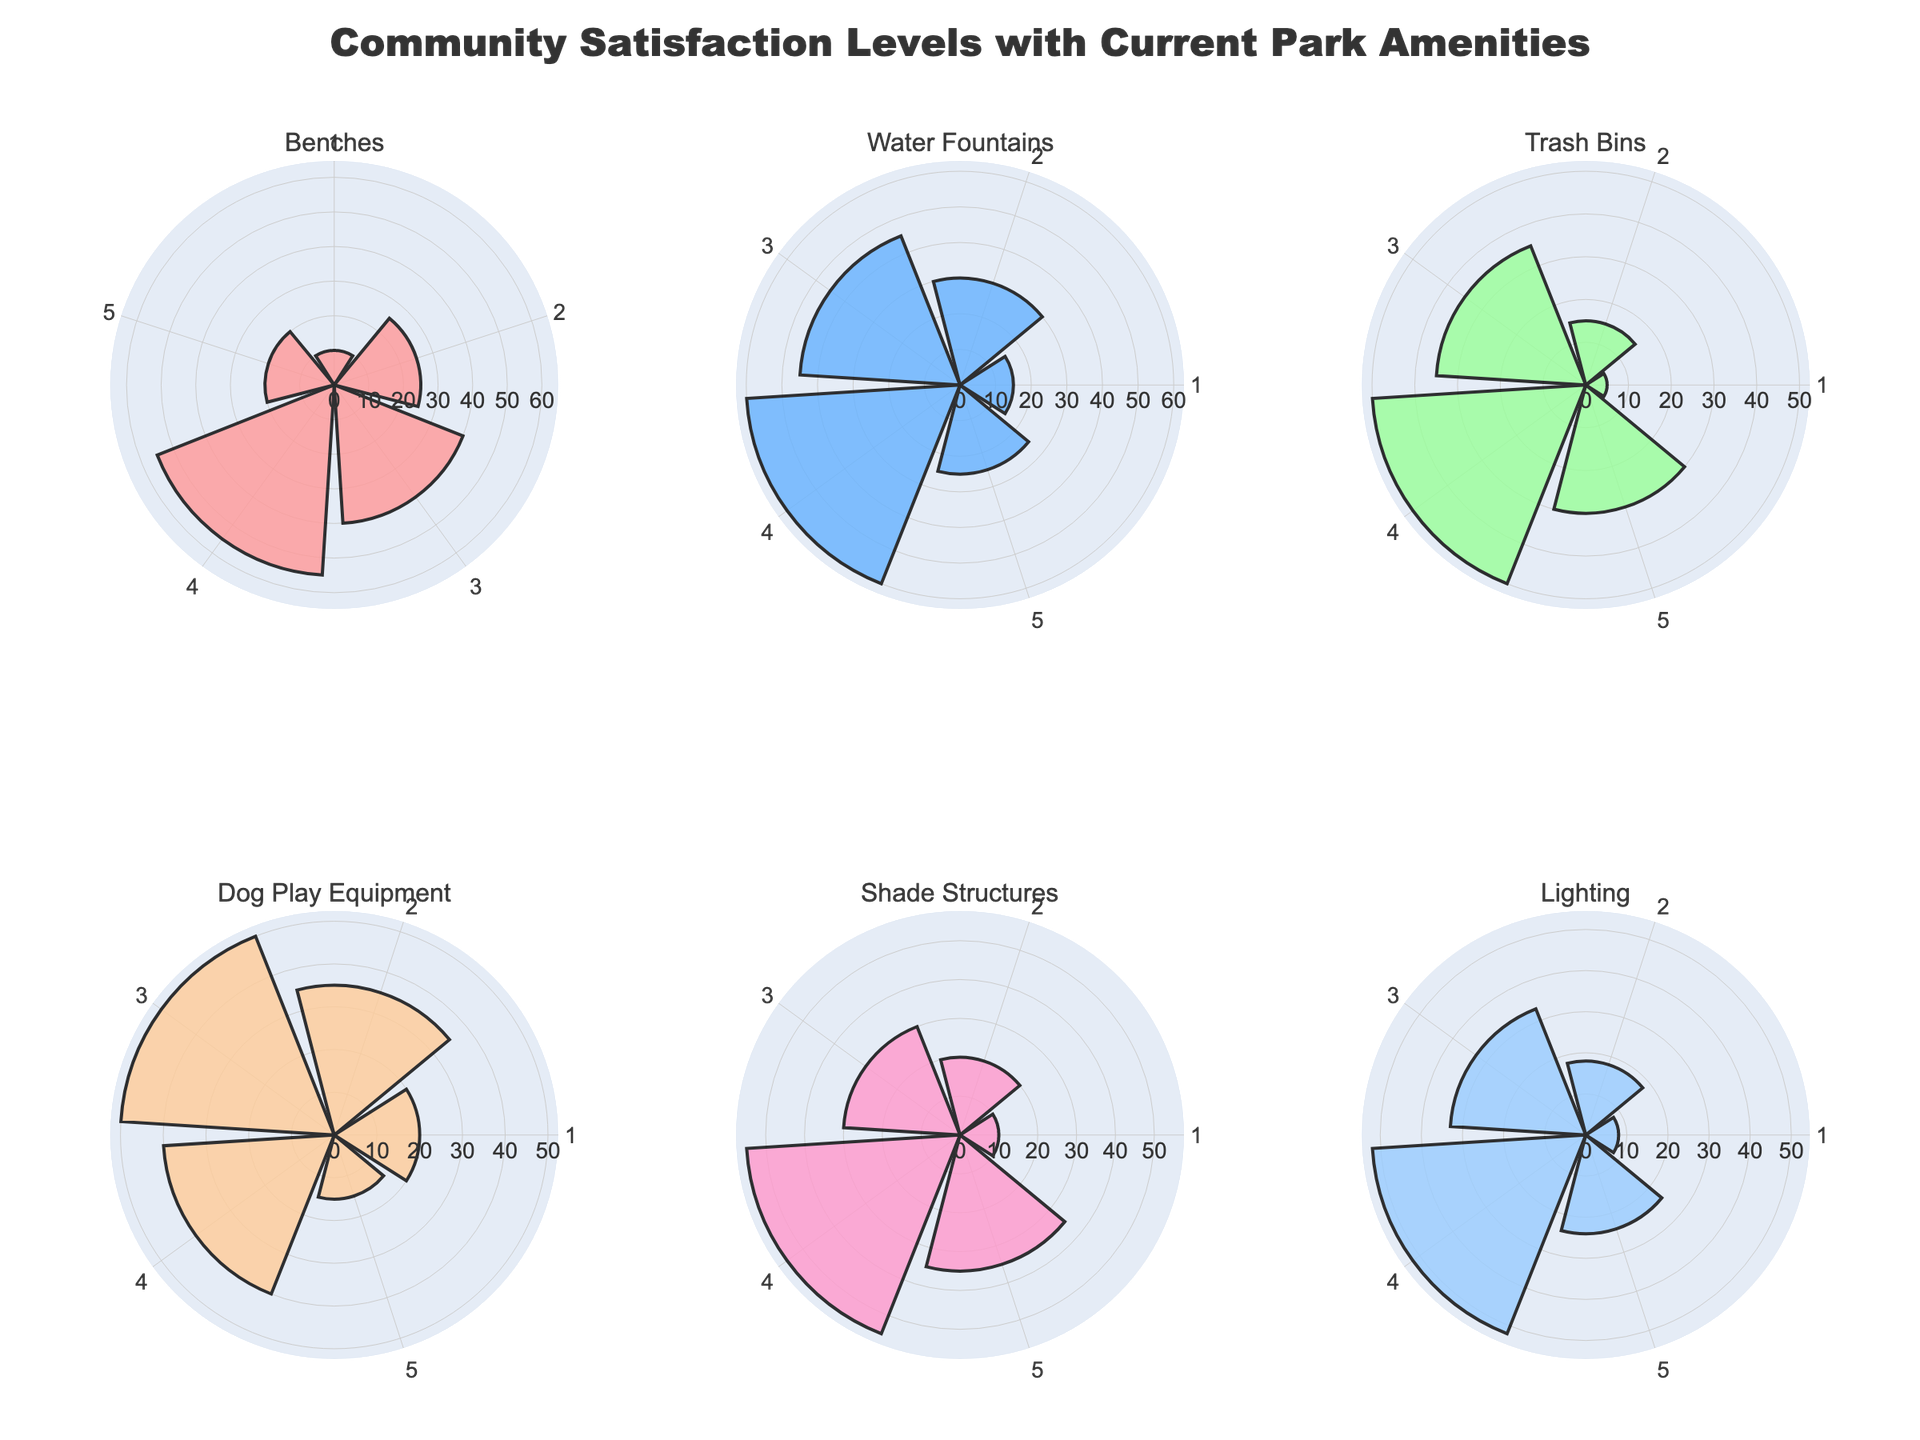How many subplots are there in the figure? There are six unique amenities listed in the data, and each amenity is represented by a subplot. Therefore, there are six subplots in total.
Answer: 6 Which amenity shows the highest satisfaction level (Rating 5) with the highest count? Shade Structures has the highest count for Rating 5 with a count of 35.
Answer: Shade Structures What is the total count of responses for the amenity 'Benches'? The counts for Benches are 10, 25, 40, 55, and 20. Adding these, 10 + 25 + 40 + 55 + 20 = 150.
Answer: 150 Which amenity has the lowest count for Rating 1? Trash Bins have the lowest count for Rating 1 with a count of 5.
Answer: Trash Bins Which rating has the highest combined count across all amenities? By adding the counts of each rating across all amenities:
- Rating 1: 10+15+5+20+10+8 = 68
- Rating 2: 25+30+15+35+20+18 = 143
- Rating 3: 40+45+35+50+30+33 = 233
- Rating 4: 55+60+50+40+55+52 = 312
- Rating 5: 20+25+30+15+35+24 = 149
Rating 4 has the highest combined count of 312.
Answer: Rating 4 Which amenity has the lowest count for Rating 4? Dog Play Equipment has the lowest count for Rating 4 with a count of 40.
Answer: Dog Play Equipment Compare the satisfaction levels for 'Water Fountains' and 'Lighting.' Which one has higher community satisfaction overall? To determine the overall satisfaction, compare the total counts for each rating.
For Water Fountains: 15+30+45+60+25 = 175
For Lighting: 8+18+33+52+24 = 135
Water Fountains have a higher total count, indicating higher community satisfaction overall.
Answer: Water Fountains What is the total count for ratings 3 and 4 combined for 'Shade Structures'? For Shade Structures: 
- Rating 3 count is 30.
- Rating 4 count is 55.
Total count for ratings 3 and 4 is 30 + 55 = 85.
Answer: 85 Which amenity has the most consistent satisfaction distribution across all ratings? Examine which amenity has counts that are relatively even across all ratings. Dog Play Equipment has counts that are relatively close to each other across the different ratings (20, 35, 50, 40, 15).
Answer: Dog Play Equipment 